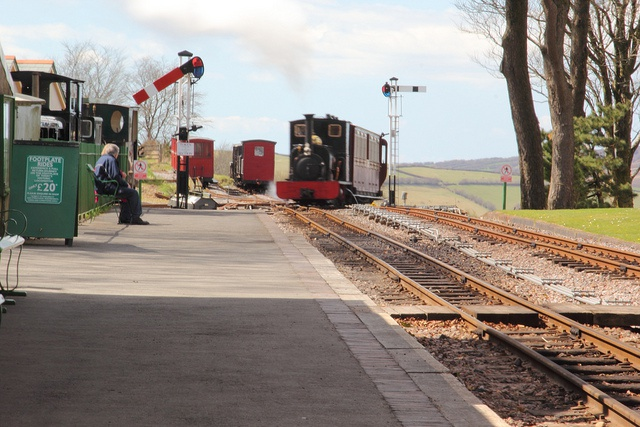Describe the objects in this image and their specific colors. I can see train in lightblue, black, darkgray, maroon, and gray tones, train in lightblue, brown, black, and gray tones, people in lightblue, black, gray, and darkgray tones, bench in lightblue, darkgray, black, tan, and gray tones, and train in lightblue, maroon, salmon, and brown tones in this image. 